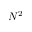<formula> <loc_0><loc_0><loc_500><loc_500>N ^ { 2 }</formula> 